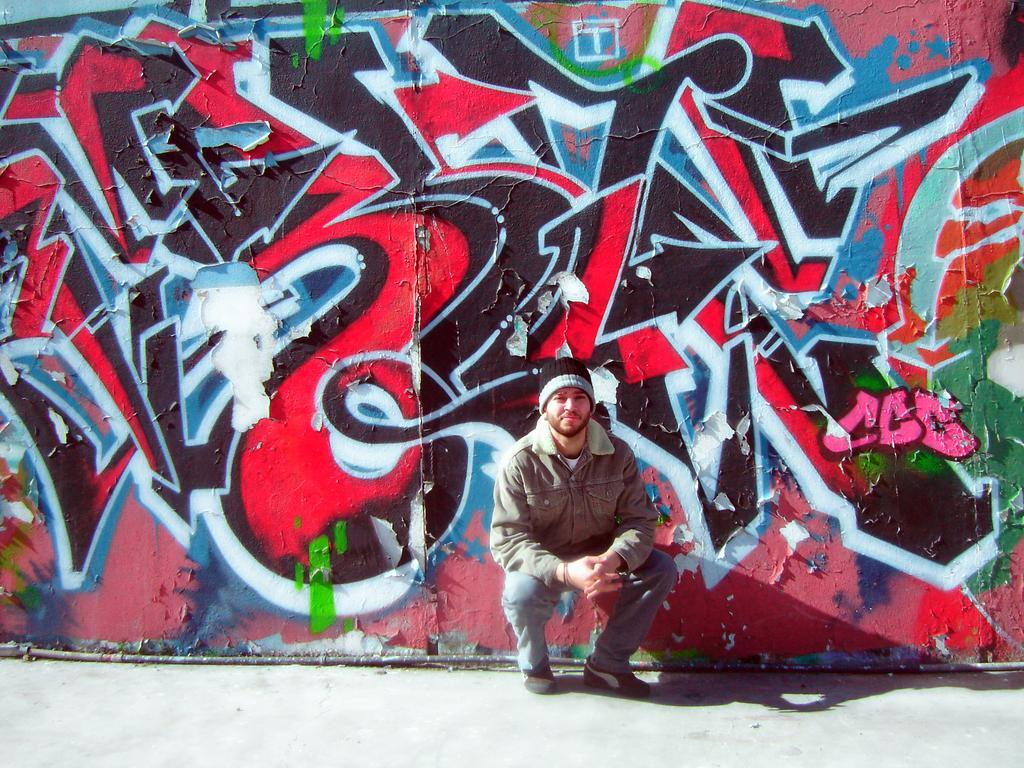In one or two sentences, can you explain what this image depicts? In the foreground it is footpath. In the center of the picture we can see a person. In the background it is wall with graffiti. 